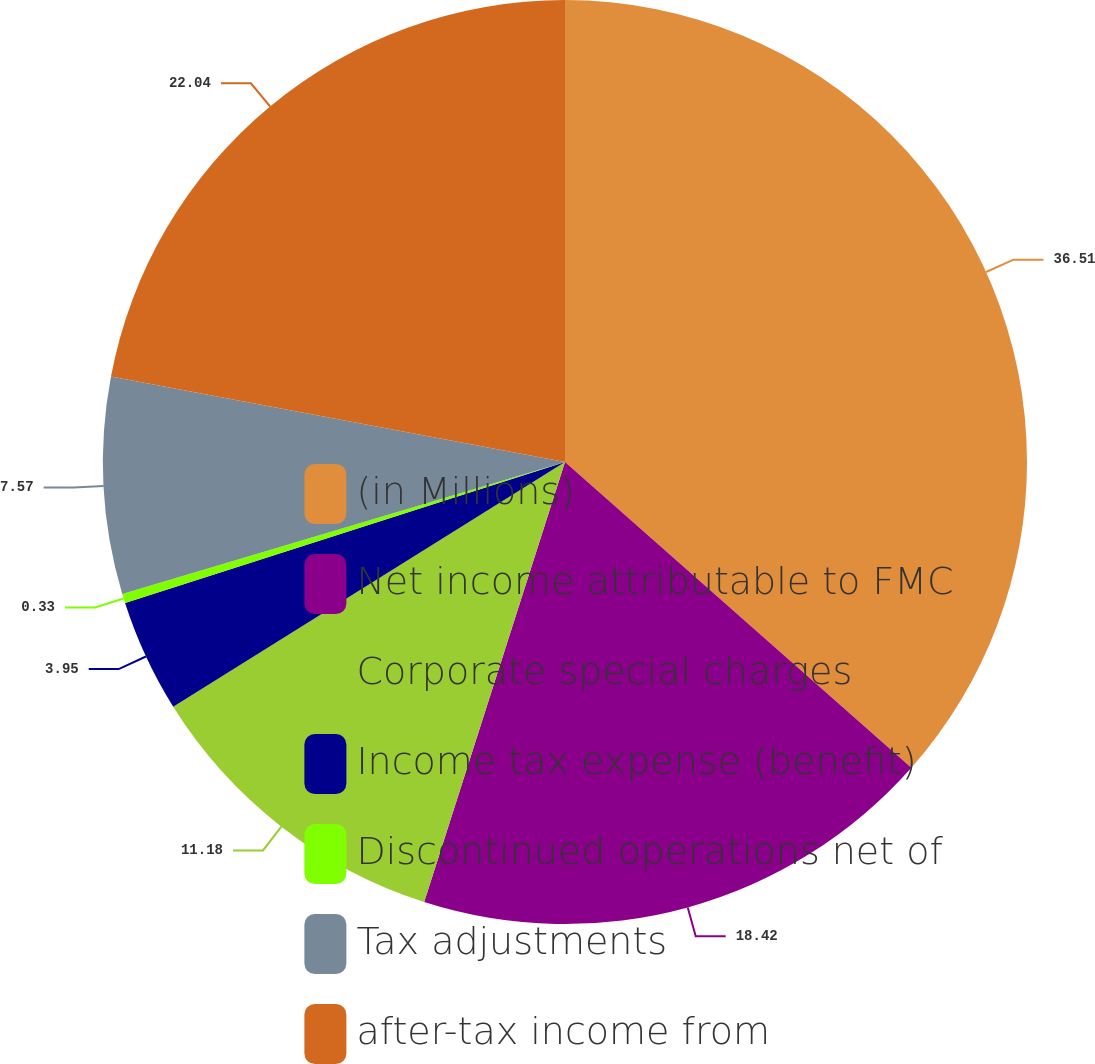Convert chart to OTSL. <chart><loc_0><loc_0><loc_500><loc_500><pie_chart><fcel>(in Millions)<fcel>Net income attributable to FMC<fcel>Corporate special charges<fcel>Income tax expense (benefit)<fcel>Discontinued operations net of<fcel>Tax adjustments<fcel>after-tax income from<nl><fcel>36.51%<fcel>18.42%<fcel>11.18%<fcel>3.95%<fcel>0.33%<fcel>7.57%<fcel>22.04%<nl></chart> 